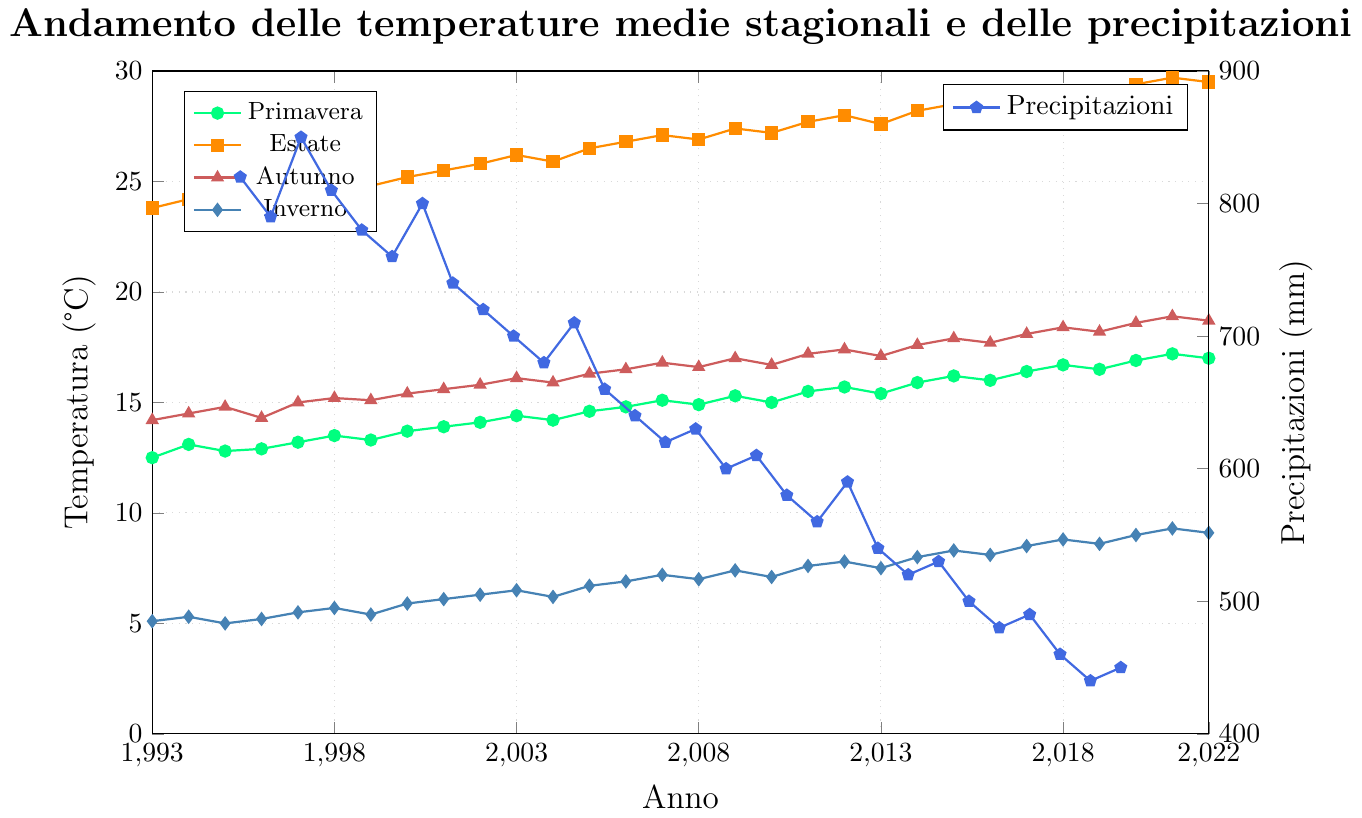What's the overall trend of the temperature in summer over the 30 years? To determine the trend, observe the temperature values for summer (color: orange) over the years from 1993 to 2022. It consistently increases over time, particularly noticeable from the early 2000s onwards.
Answer: Increasing Which season had the highest temperature in 2022? From the figure, observe the 2022 values. Compare the points for each season. The summer temperature is the highest at approximately 29.5°C.
Answer: Summer By how much did the autumn temperature increase from 1993 to 2022? Look at the autumn temperature values for 1993 (14.2°C) and 2022 (18.7°C). Subtract the initial value from the final value: 18.7 - 14.2 = 4.5°C.
Answer: 4.5°C What was the year with the lowest annual precipitation? Observe the precipitation line (color: blue) and identify the lowest point on the chart. The lowest annual precipitation occurs in 2021 at 440 mm.
Answer: 2021 Compare the average winter temperature from 1993-2002 and 2013-2022. Which decade was warmer on average? Calculate the average winter temperatures for both decades:
- 1993-2002: (5.1 + 5.3 + 5.0 + 5.2 + 5.5 + 5.7 + 5.4 + 5.9 + 6.1 + 6.3) / 10 = 55.5 / 10 = 5.55°C
- 2013-2022: (7.5 + 8.0 + 8.3 + 8.1 + 8.5 + 8.8 + 8.6 + 9.0 + 9.3 + 9.1) / 10 = 85.2 / 10 = 8.52°C
Comparing the results, the decade 2013-2022 is warmer.
Answer: 2013-2022 What was the rate of change in spring temperature between 1993 and 2022? The rate of change is given by (final value - initial value) / initial value. For spring, in 1993 it was 12.5°C and in 2022 it was 17.0°C. So, the rate is (17.0 - 12.5) / 12.5 ≈ 0.36 or 36%.
Answer: 36% What is the greatest variation in temperature within a single year? Compare the temperature ranges (difference between highest and lowest season values) for each year. For example, in 2022, the highest is 29.5°C (summer) and the lowest is 9.1°C (winter); the range is 29.5 - 9.1 = 20.4°C. Looking across all years, the one with the greatest range needs detailed calculation for each, and typically the later years show higher variations. From inspection, 2020 has significant variation roughly around 29.4 - 9.0 = 20.4°C, which can be cross-checked for the largest range over the 30-year span.
Answer: 2022 and 2020 (approximately equal) How did the spring temperature change every 10 years from 1993 to 2022? Calculate the temperature change over each 10-year period:
- 1993-2003: 14.4 - 12.5 = 1.9°C,
- 2003-2013: 15.4 - 14.4 = 1.0°C,
- 2013-2022: 17.0 - 15.4 = 1.6°C.
The temperature generally increased in each 10-year interval.
Answer: 1.9°C, 1.0°C, 1.6°C What relationship can be derived between precipitation and temperature over the years? Observe the two trends. As the average temperatures (in all seasons) rise over the years, the annual precipitation decreases. This suggests an inverse relationship where higher temperatures correlate with lower precipitation when viewed over this 30-year period.
Answer: Inverse relationship 